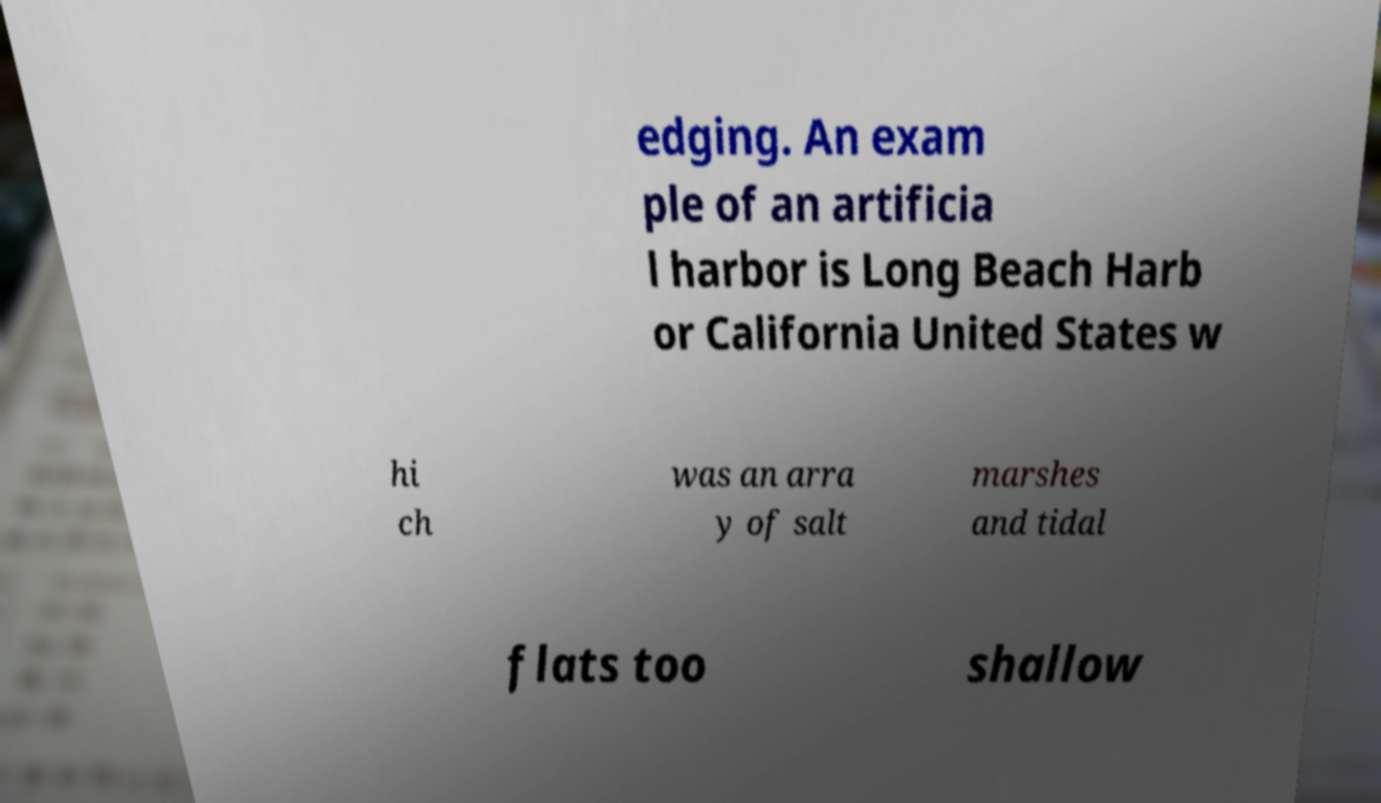Can you accurately transcribe the text from the provided image for me? edging. An exam ple of an artificia l harbor is Long Beach Harb or California United States w hi ch was an arra y of salt marshes and tidal flats too shallow 